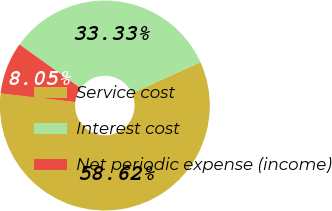<chart> <loc_0><loc_0><loc_500><loc_500><pie_chart><fcel>Service cost<fcel>Interest cost<fcel>Net periodic expense (income)<nl><fcel>58.62%<fcel>33.33%<fcel>8.05%<nl></chart> 